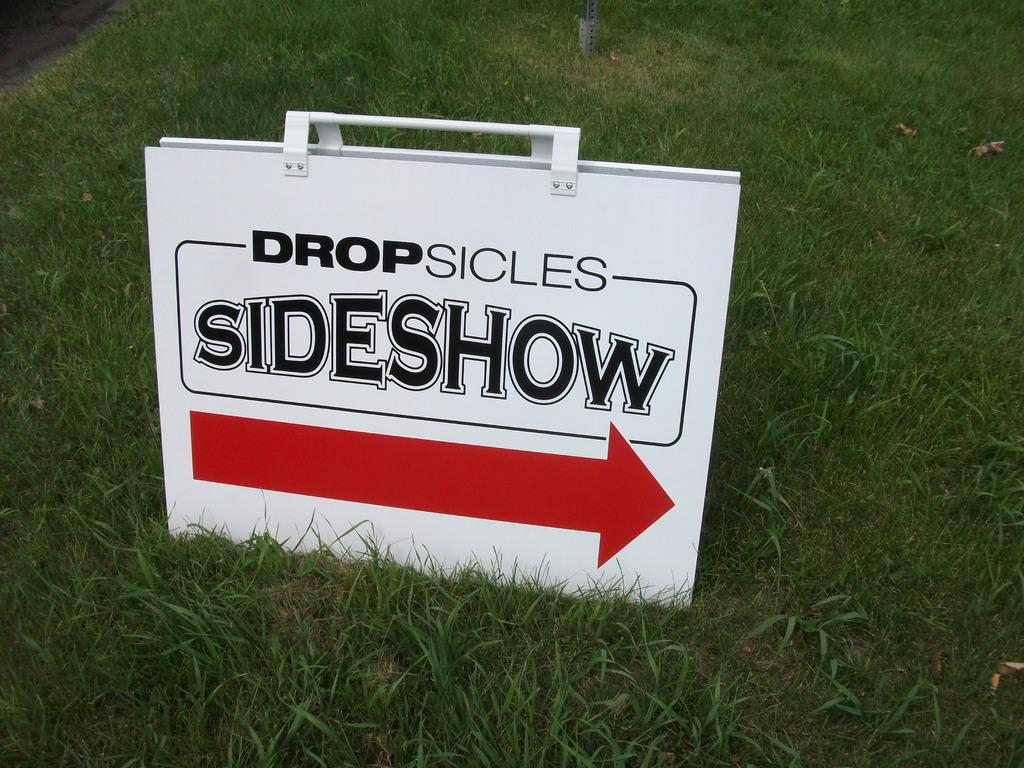What is the main object in the image? There is a white box or board in the image. What is written on the box or board? The text "SIDESHOW" is written on the box or board. What is the red arrow on the box or board pointing to? The red arrow is drawn on the box or board, but its direction or purpose is not specified in the facts. What type of natural environment is visible in the image? Grass is visible at the bottom of the image. Can you tell me how many pigs are present in the image? There is no mention of pigs in the image or the provided facts. 